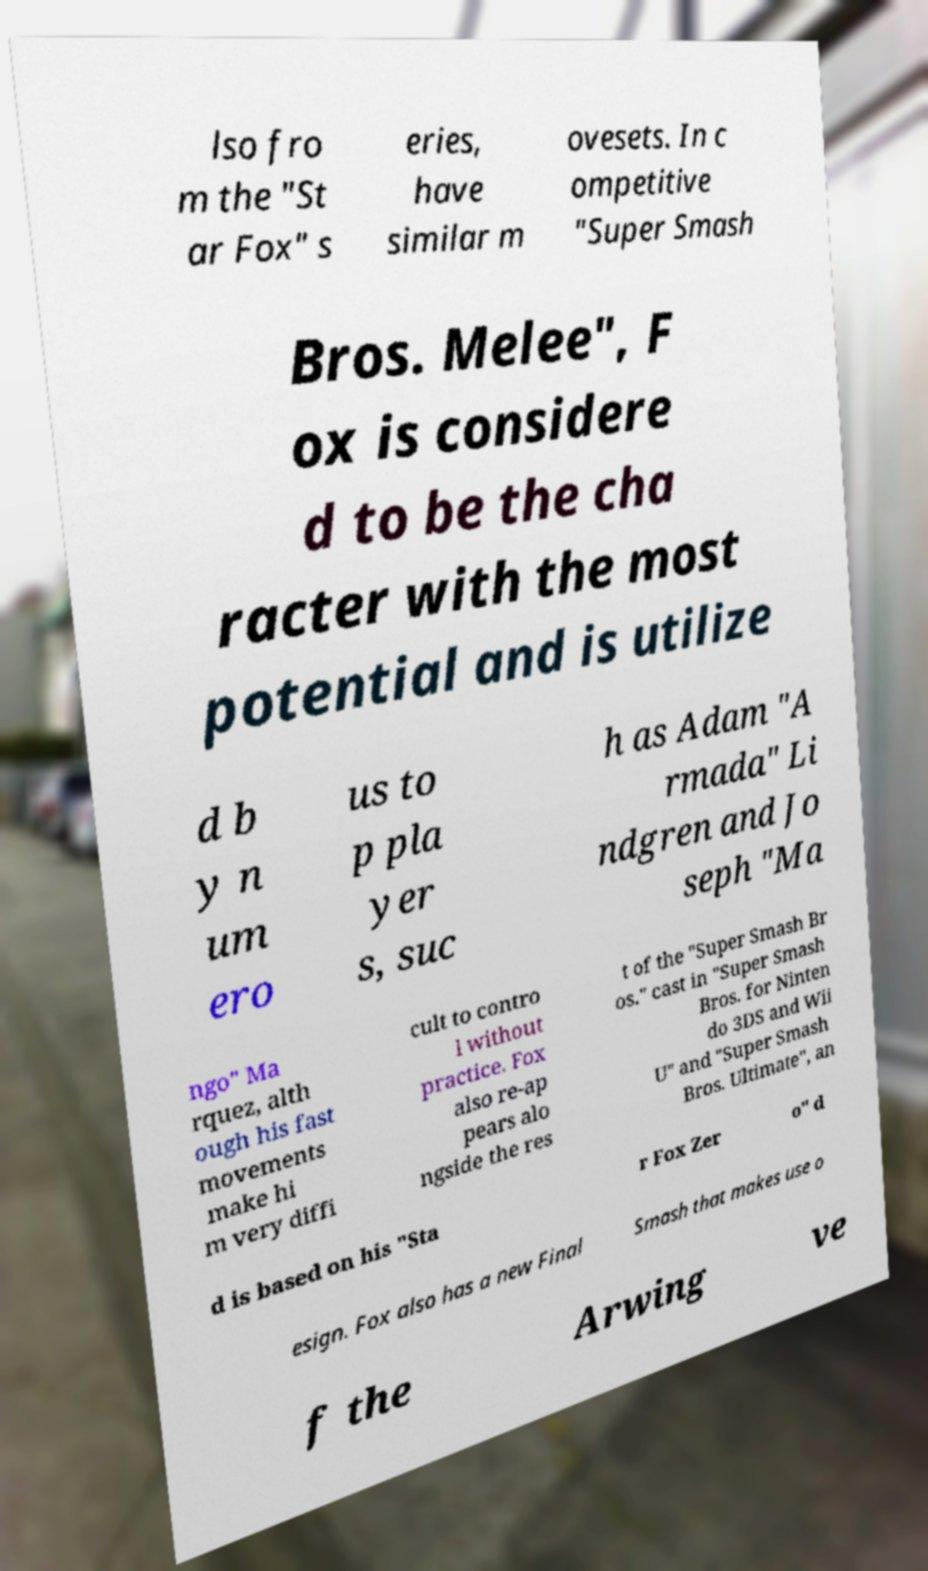What messages or text are displayed in this image? I need them in a readable, typed format. lso fro m the "St ar Fox" s eries, have similar m ovesets. In c ompetitive "Super Smash Bros. Melee", F ox is considere d to be the cha racter with the most potential and is utilize d b y n um ero us to p pla yer s, suc h as Adam "A rmada" Li ndgren and Jo seph "Ma ngo" Ma rquez, alth ough his fast movements make hi m very diffi cult to contro l without practice. Fox also re-ap pears alo ngside the res t of the "Super Smash Br os." cast in "Super Smash Bros. for Ninten do 3DS and Wii U" and "Super Smash Bros. Ultimate", an d is based on his "Sta r Fox Zer o" d esign. Fox also has a new Final Smash that makes use o f the Arwing ve 